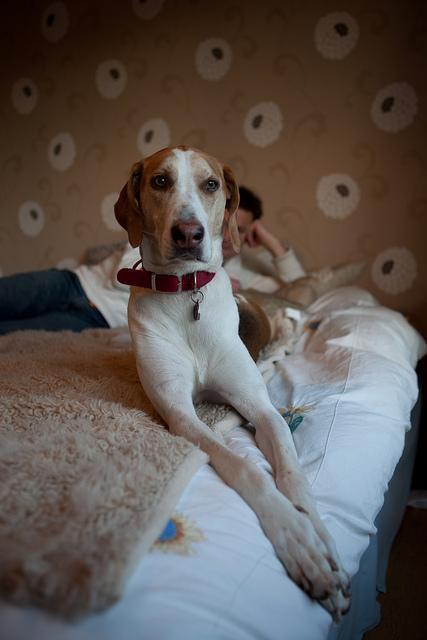What is the purpose of the item tied around his neck?
Make your selection from the four choices given to correctly answer the question.
Options: Choking, fashion, identification, breathing. Identification. 